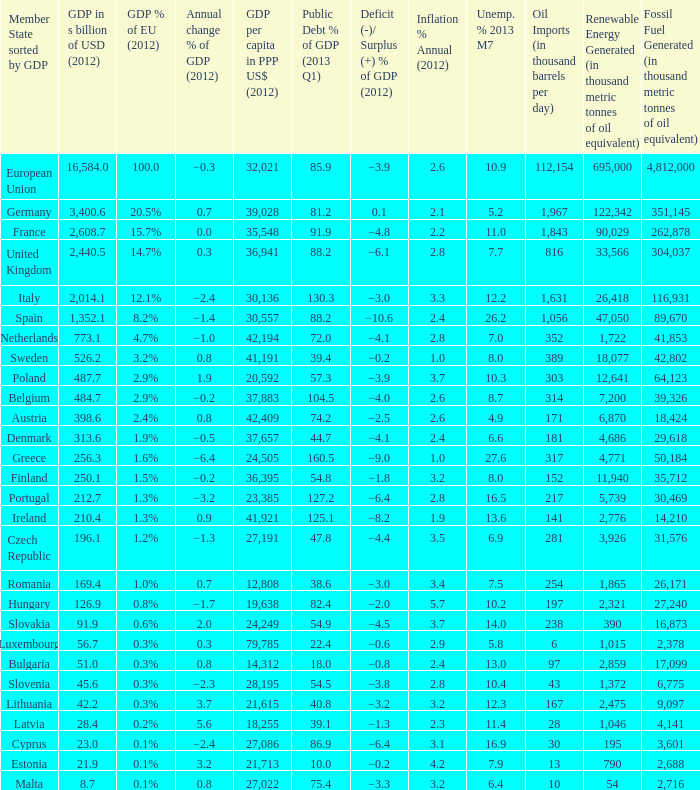What is the GDP % of EU in 2012 of the country with a GDP in billions of USD in 2012 of 256.3? 1.6%. 